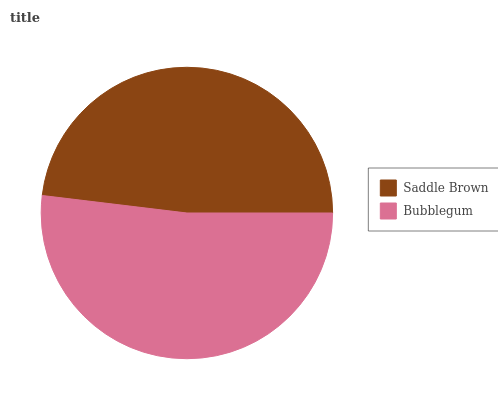Is Saddle Brown the minimum?
Answer yes or no. Yes. Is Bubblegum the maximum?
Answer yes or no. Yes. Is Bubblegum the minimum?
Answer yes or no. No. Is Bubblegum greater than Saddle Brown?
Answer yes or no. Yes. Is Saddle Brown less than Bubblegum?
Answer yes or no. Yes. Is Saddle Brown greater than Bubblegum?
Answer yes or no. No. Is Bubblegum less than Saddle Brown?
Answer yes or no. No. Is Bubblegum the high median?
Answer yes or no. Yes. Is Saddle Brown the low median?
Answer yes or no. Yes. Is Saddle Brown the high median?
Answer yes or no. No. Is Bubblegum the low median?
Answer yes or no. No. 